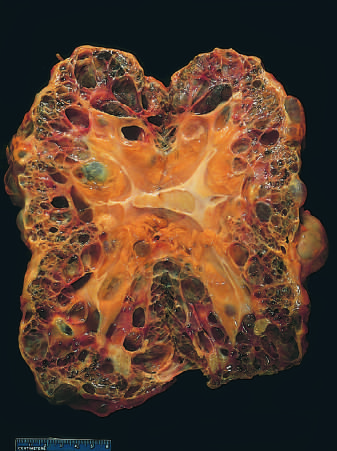s the kidney markedly enlarged?
Answer the question using a single word or phrase. Yes 